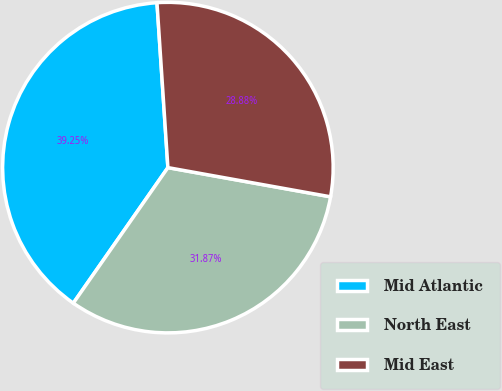Convert chart. <chart><loc_0><loc_0><loc_500><loc_500><pie_chart><fcel>Mid Atlantic<fcel>North East<fcel>Mid East<nl><fcel>39.25%<fcel>31.87%<fcel>28.88%<nl></chart> 